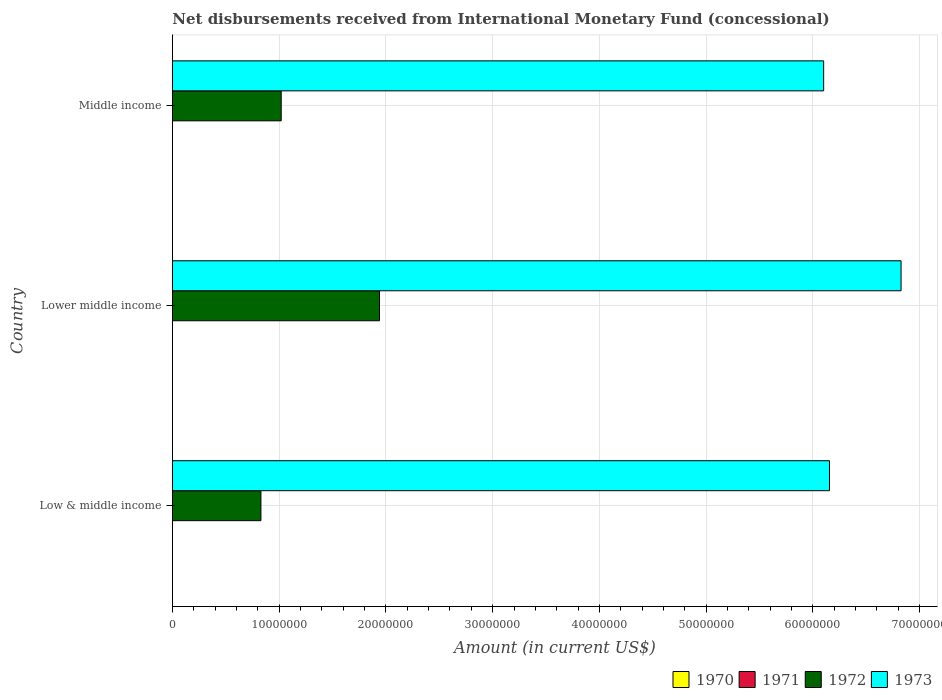Are the number of bars per tick equal to the number of legend labels?
Provide a short and direct response. No. Are the number of bars on each tick of the Y-axis equal?
Offer a terse response. Yes. How many bars are there on the 3rd tick from the top?
Your answer should be compact. 2. How many bars are there on the 3rd tick from the bottom?
Offer a terse response. 2. What is the label of the 2nd group of bars from the top?
Provide a succinct answer. Lower middle income. What is the amount of disbursements received from International Monetary Fund in 1973 in Lower middle income?
Ensure brevity in your answer.  6.83e+07. Across all countries, what is the maximum amount of disbursements received from International Monetary Fund in 1973?
Ensure brevity in your answer.  6.83e+07. Across all countries, what is the minimum amount of disbursements received from International Monetary Fund in 1971?
Your answer should be compact. 0. In which country was the amount of disbursements received from International Monetary Fund in 1972 maximum?
Keep it short and to the point. Lower middle income. What is the total amount of disbursements received from International Monetary Fund in 1973 in the graph?
Provide a short and direct response. 1.91e+08. What is the difference between the amount of disbursements received from International Monetary Fund in 1973 in Low & middle income and that in Lower middle income?
Ensure brevity in your answer.  -6.70e+06. What is the difference between the amount of disbursements received from International Monetary Fund in 1973 in Middle income and the amount of disbursements received from International Monetary Fund in 1970 in Low & middle income?
Ensure brevity in your answer.  6.10e+07. What is the average amount of disbursements received from International Monetary Fund in 1973 per country?
Your answer should be very brief. 6.36e+07. What is the difference between the amount of disbursements received from International Monetary Fund in 1973 and amount of disbursements received from International Monetary Fund in 1972 in Lower middle income?
Make the answer very short. 4.89e+07. In how many countries, is the amount of disbursements received from International Monetary Fund in 1972 greater than 26000000 US$?
Make the answer very short. 0. What is the ratio of the amount of disbursements received from International Monetary Fund in 1973 in Low & middle income to that in Lower middle income?
Offer a very short reply. 0.9. Is the amount of disbursements received from International Monetary Fund in 1973 in Low & middle income less than that in Lower middle income?
Offer a terse response. Yes. What is the difference between the highest and the second highest amount of disbursements received from International Monetary Fund in 1972?
Offer a terse response. 9.21e+06. What is the difference between the highest and the lowest amount of disbursements received from International Monetary Fund in 1972?
Keep it short and to the point. 1.11e+07. Is it the case that in every country, the sum of the amount of disbursements received from International Monetary Fund in 1973 and amount of disbursements received from International Monetary Fund in 1972 is greater than the sum of amount of disbursements received from International Monetary Fund in 1970 and amount of disbursements received from International Monetary Fund in 1971?
Give a very brief answer. Yes. Is it the case that in every country, the sum of the amount of disbursements received from International Monetary Fund in 1971 and amount of disbursements received from International Monetary Fund in 1973 is greater than the amount of disbursements received from International Monetary Fund in 1970?
Give a very brief answer. Yes. How many bars are there?
Offer a very short reply. 6. Are all the bars in the graph horizontal?
Make the answer very short. Yes. How many countries are there in the graph?
Provide a succinct answer. 3. Does the graph contain any zero values?
Your answer should be compact. Yes. Where does the legend appear in the graph?
Your answer should be very brief. Bottom right. How many legend labels are there?
Give a very brief answer. 4. What is the title of the graph?
Your answer should be compact. Net disbursements received from International Monetary Fund (concessional). Does "1992" appear as one of the legend labels in the graph?
Provide a succinct answer. No. What is the label or title of the X-axis?
Ensure brevity in your answer.  Amount (in current US$). What is the label or title of the Y-axis?
Your answer should be very brief. Country. What is the Amount (in current US$) in 1971 in Low & middle income?
Offer a very short reply. 0. What is the Amount (in current US$) in 1972 in Low & middle income?
Offer a very short reply. 8.30e+06. What is the Amount (in current US$) of 1973 in Low & middle income?
Make the answer very short. 6.16e+07. What is the Amount (in current US$) in 1970 in Lower middle income?
Keep it short and to the point. 0. What is the Amount (in current US$) of 1972 in Lower middle income?
Ensure brevity in your answer.  1.94e+07. What is the Amount (in current US$) of 1973 in Lower middle income?
Offer a very short reply. 6.83e+07. What is the Amount (in current US$) of 1971 in Middle income?
Offer a very short reply. 0. What is the Amount (in current US$) in 1972 in Middle income?
Your answer should be very brief. 1.02e+07. What is the Amount (in current US$) of 1973 in Middle income?
Keep it short and to the point. 6.10e+07. Across all countries, what is the maximum Amount (in current US$) in 1972?
Offer a very short reply. 1.94e+07. Across all countries, what is the maximum Amount (in current US$) of 1973?
Your answer should be very brief. 6.83e+07. Across all countries, what is the minimum Amount (in current US$) of 1972?
Your response must be concise. 8.30e+06. Across all countries, what is the minimum Amount (in current US$) in 1973?
Provide a short and direct response. 6.10e+07. What is the total Amount (in current US$) in 1972 in the graph?
Make the answer very short. 3.79e+07. What is the total Amount (in current US$) of 1973 in the graph?
Your answer should be very brief. 1.91e+08. What is the difference between the Amount (in current US$) of 1972 in Low & middle income and that in Lower middle income?
Keep it short and to the point. -1.11e+07. What is the difference between the Amount (in current US$) in 1973 in Low & middle income and that in Lower middle income?
Provide a succinct answer. -6.70e+06. What is the difference between the Amount (in current US$) of 1972 in Low & middle income and that in Middle income?
Ensure brevity in your answer.  -1.90e+06. What is the difference between the Amount (in current US$) of 1973 in Low & middle income and that in Middle income?
Offer a terse response. 5.46e+05. What is the difference between the Amount (in current US$) of 1972 in Lower middle income and that in Middle income?
Make the answer very short. 9.21e+06. What is the difference between the Amount (in current US$) of 1973 in Lower middle income and that in Middle income?
Offer a terse response. 7.25e+06. What is the difference between the Amount (in current US$) in 1972 in Low & middle income and the Amount (in current US$) in 1973 in Lower middle income?
Make the answer very short. -6.00e+07. What is the difference between the Amount (in current US$) in 1972 in Low & middle income and the Amount (in current US$) in 1973 in Middle income?
Keep it short and to the point. -5.27e+07. What is the difference between the Amount (in current US$) of 1972 in Lower middle income and the Amount (in current US$) of 1973 in Middle income?
Your answer should be very brief. -4.16e+07. What is the average Amount (in current US$) of 1971 per country?
Your answer should be very brief. 0. What is the average Amount (in current US$) in 1972 per country?
Give a very brief answer. 1.26e+07. What is the average Amount (in current US$) of 1973 per country?
Offer a terse response. 6.36e+07. What is the difference between the Amount (in current US$) in 1972 and Amount (in current US$) in 1973 in Low & middle income?
Your answer should be very brief. -5.33e+07. What is the difference between the Amount (in current US$) of 1972 and Amount (in current US$) of 1973 in Lower middle income?
Keep it short and to the point. -4.89e+07. What is the difference between the Amount (in current US$) of 1972 and Amount (in current US$) of 1973 in Middle income?
Make the answer very short. -5.08e+07. What is the ratio of the Amount (in current US$) of 1972 in Low & middle income to that in Lower middle income?
Ensure brevity in your answer.  0.43. What is the ratio of the Amount (in current US$) of 1973 in Low & middle income to that in Lower middle income?
Ensure brevity in your answer.  0.9. What is the ratio of the Amount (in current US$) of 1972 in Low & middle income to that in Middle income?
Make the answer very short. 0.81. What is the ratio of the Amount (in current US$) in 1973 in Low & middle income to that in Middle income?
Offer a very short reply. 1.01. What is the ratio of the Amount (in current US$) of 1972 in Lower middle income to that in Middle income?
Keep it short and to the point. 1.9. What is the ratio of the Amount (in current US$) of 1973 in Lower middle income to that in Middle income?
Make the answer very short. 1.12. What is the difference between the highest and the second highest Amount (in current US$) of 1972?
Offer a very short reply. 9.21e+06. What is the difference between the highest and the second highest Amount (in current US$) of 1973?
Your answer should be compact. 6.70e+06. What is the difference between the highest and the lowest Amount (in current US$) in 1972?
Your answer should be very brief. 1.11e+07. What is the difference between the highest and the lowest Amount (in current US$) in 1973?
Keep it short and to the point. 7.25e+06. 